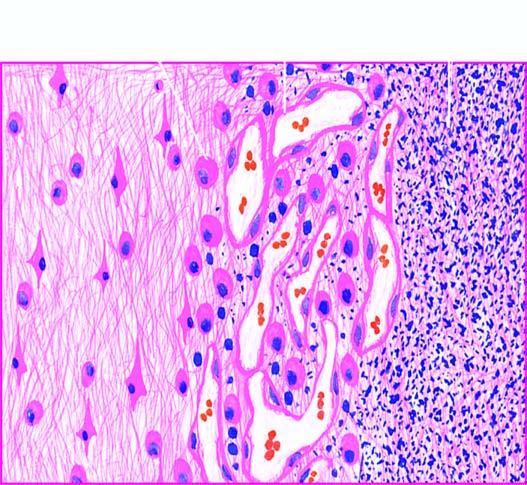what shows granulation tissue and gliosis?
Answer the question using a single word or phrase. The surrounding zone gliosis 